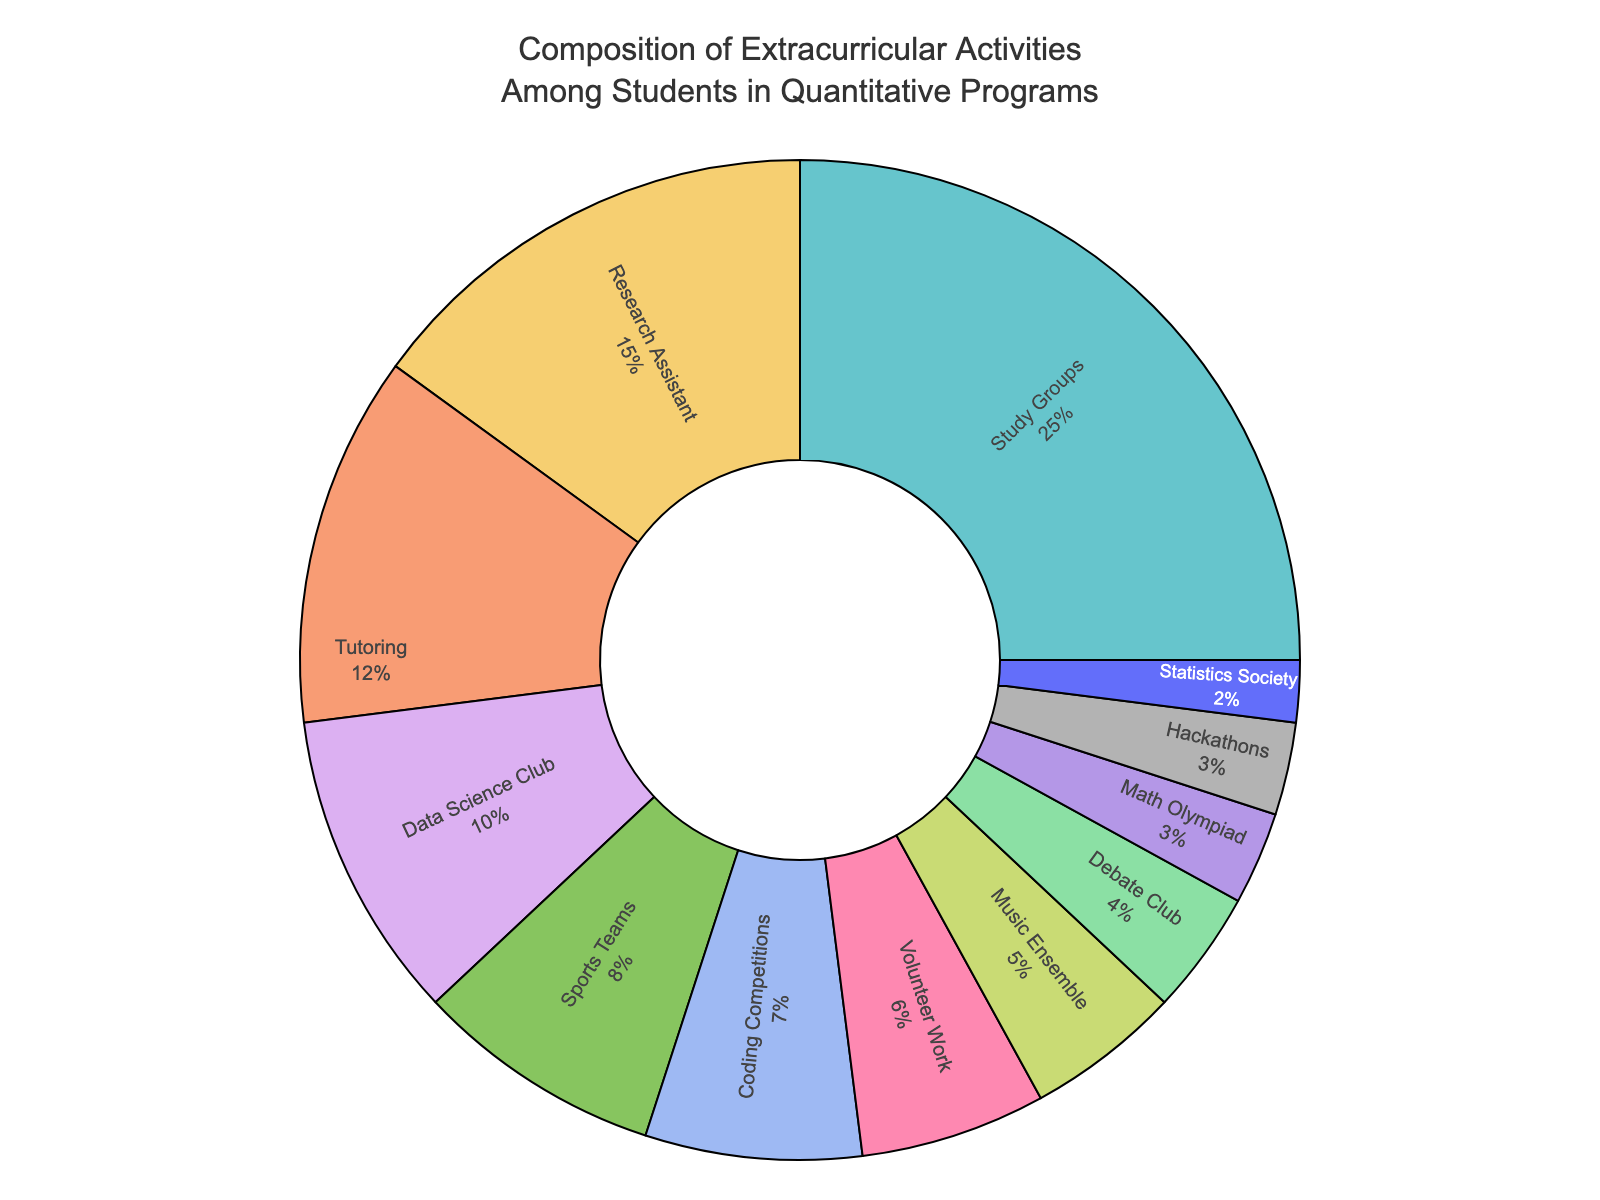What is the percentage difference between students involved in Study Groups and those in Research Assistant roles? The percentage for Study Groups is 25%, and for Research Assistant is 15%. The difference is 25% - 15% = 10%.
Answer: 10% Which activity has a higher percentage, Data Science Club or Sports Teams? Data Science Club has a percentage of 10%, while Sports Teams have 8%. Therefore, Data Science Club has a higher percentage.
Answer: Data Science Club Combine the percentages of Coding Competitions, Volunteer Work, and Music Ensemble. What is the total? Coding Competitions have 7%, Volunteer Work has 6%, and Music Ensemble has 5%. Adding them together: 7% + 6% + 5% = 18%.
Answer: 18% Out of Tutoring, Debate Club, and Math Olympiad, which one has the smallest percentage? The percentages are Tutoring (12%), Debate Club (4%), and Math Olympiad (3%). The smallest one is Math Olympiad with 3%.
Answer: Math Olympiad What proportion of students are engaged in the top three activities? The top three activities are Study Groups (25%), Research Assistant (15%), and Tutoring (12%). Summing them: 25% + 15% + 12% = 52%.
Answer: 52% Between Hackathons and Statistics Society, which has a lower percentage, and by how much? Hackathons have 3% and Statistics Society has 2%. The difference is 3% - 2% = 1%.
Answer: Statistics Society, 1% If we combine all activities with percentages less than 5%, what is the combined percentage? The activities with percentages less than 5% are Debate Club (4%), Math Olympiad (3%), Hackathons (3%), and Statistics Society (2%). Summing them: 4% + 3% + 3% + 2% = 12%.
Answer: 12% What is the sum of percentages for sports and music-related activities? Sports Teams have 8% and Music Ensemble has 5%. Adding them gives: 8% + 5% = 13%.
Answer: 13% 